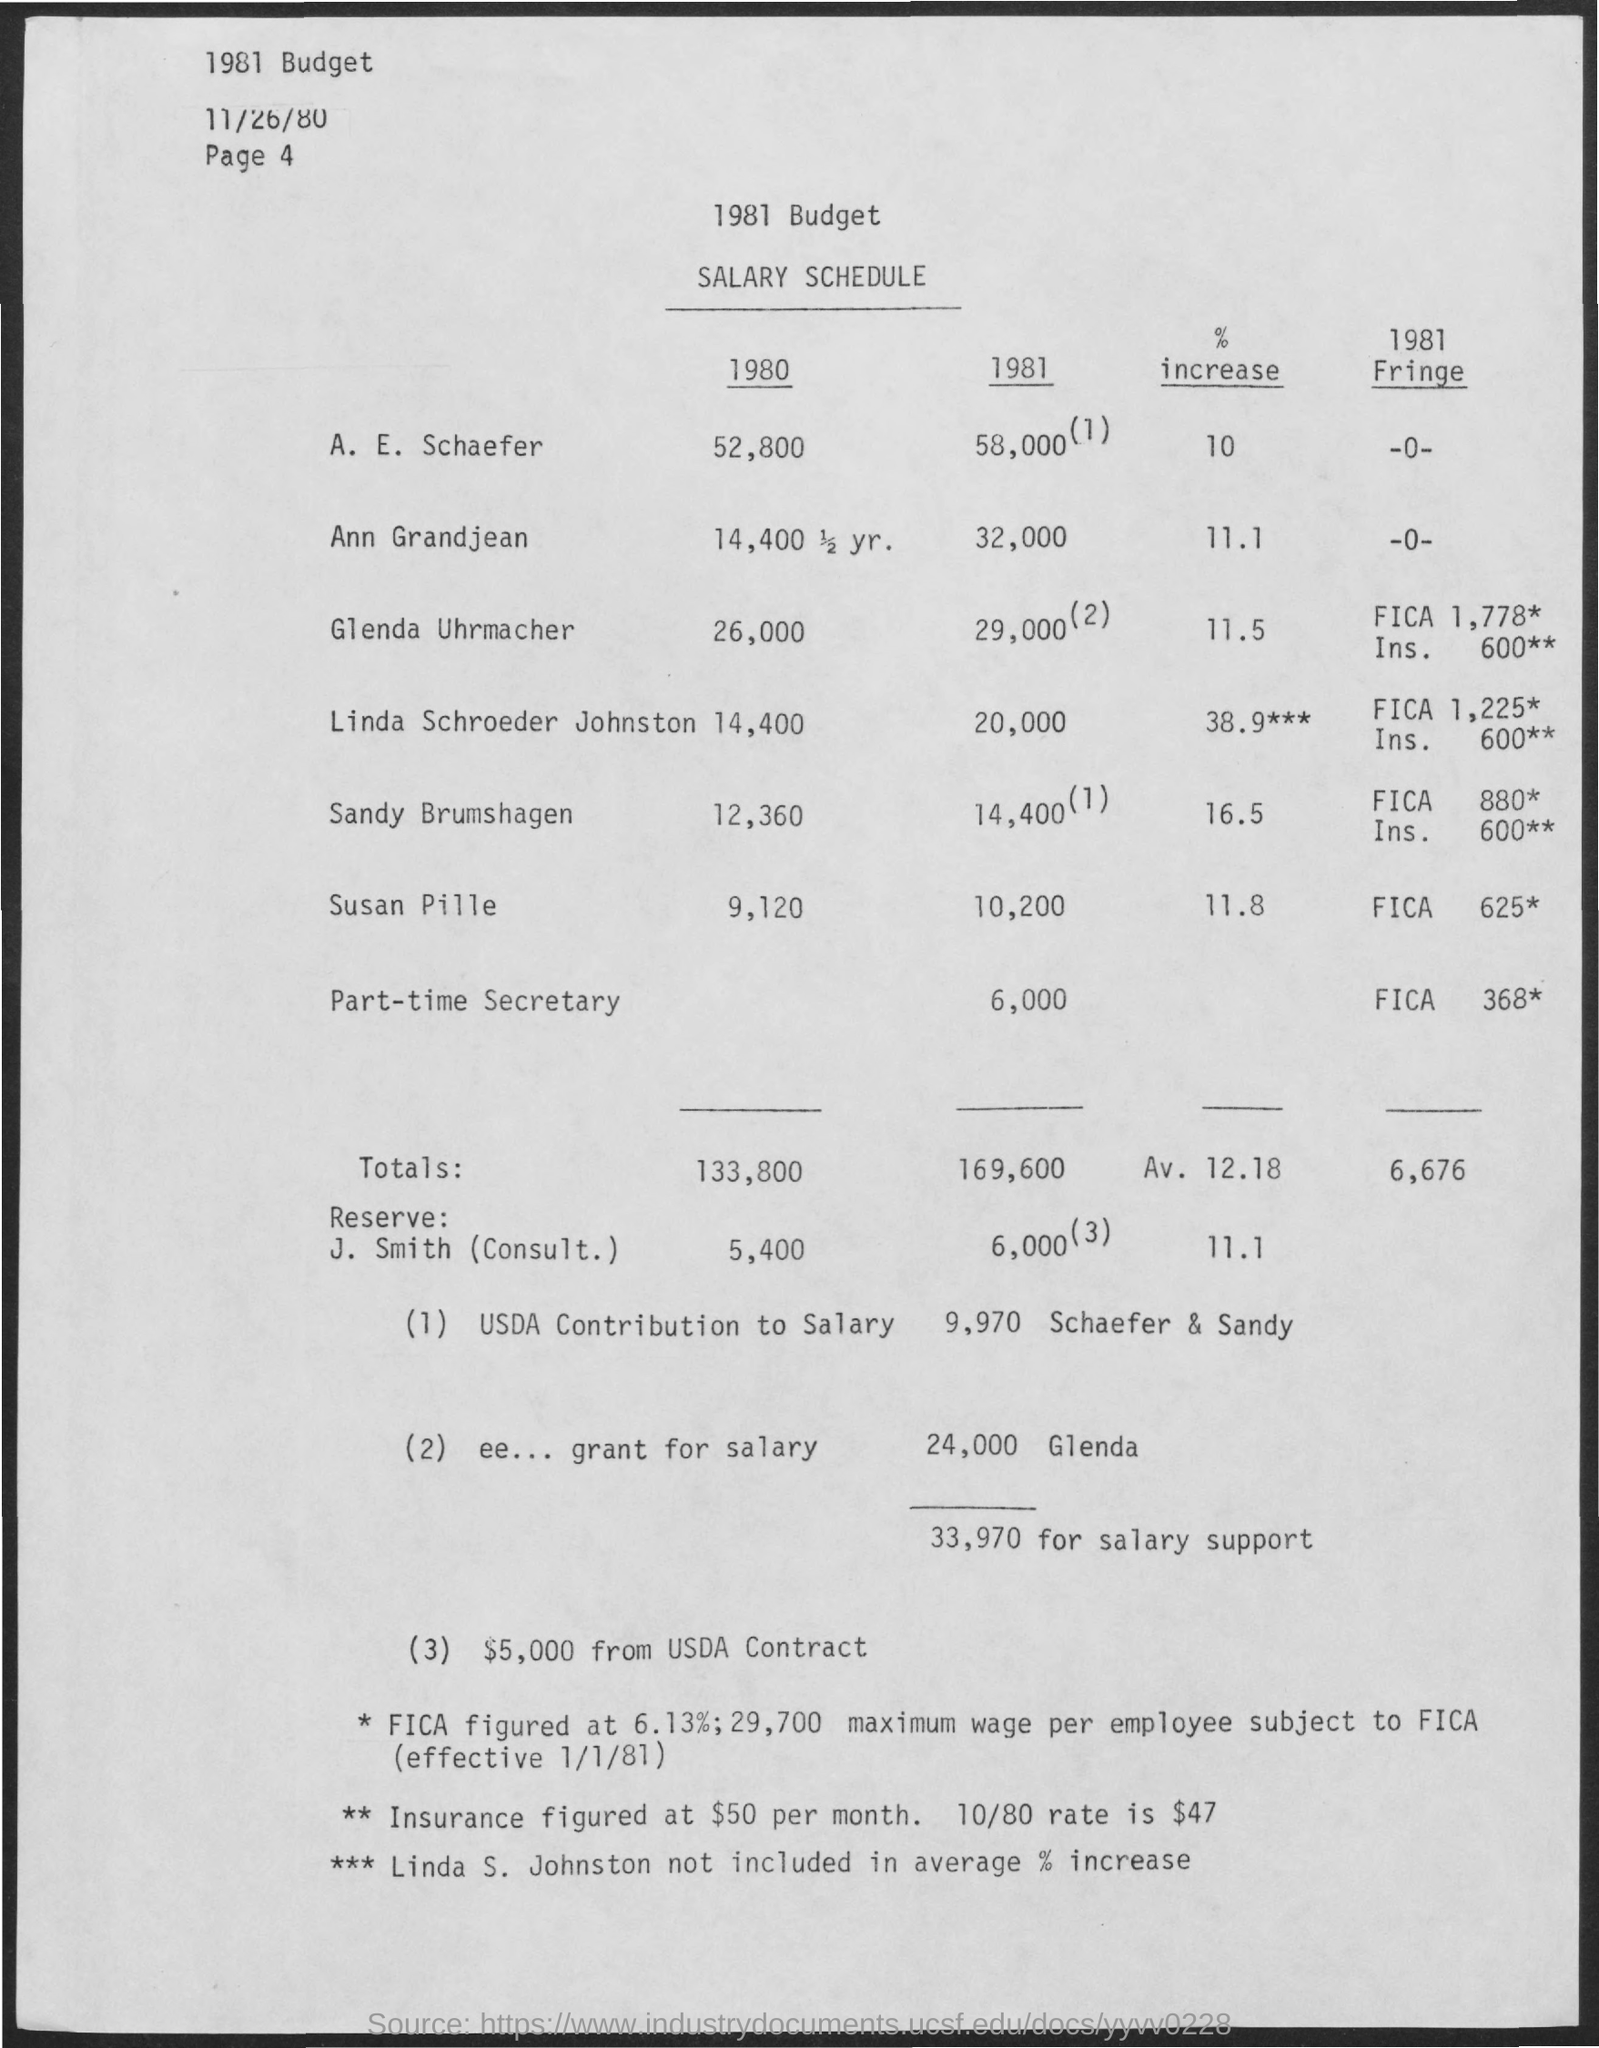Draw attention to some important aspects in this diagram. According to the provided information, Ann Grandjean's salary has experienced a % increase of 11.1... The salary of A.E. Schaefer in the year 1980 was 52,800. 